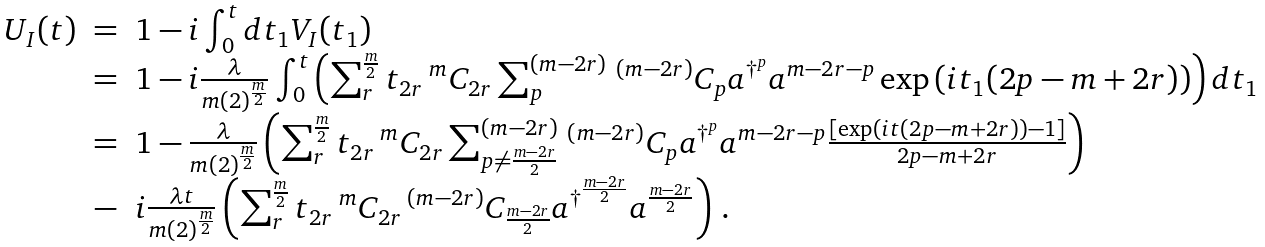Convert formula to latex. <formula><loc_0><loc_0><loc_500><loc_500>\begin{array} { l c l } U _ { I } ( t ) & = & 1 - i \int ^ { t } _ { 0 } d t _ { 1 } V _ { I } ( t _ { 1 } ) \\ & = & 1 - i \frac { \lambda } { m ( 2 ) ^ { \frac { m } { 2 } } } \int ^ { t } _ { 0 } \left ( \sum ^ { \frac { m } { 2 } } _ { r } t _ { 2 r } \, ^ { m } C _ { 2 r } \sum ^ { ( m - 2 r ) } _ { p } \, ^ { ( m - 2 r ) } C _ { p } a ^ { \dagger ^ { p } } a ^ { m - 2 r - p } \exp \left ( i t _ { 1 } ( 2 p - m + 2 r ) \right ) \right ) d t _ { 1 } \\ & = & 1 - \frac { \lambda } { m ( 2 ) ^ { \frac { m } { 2 } } } \left ( \sum ^ { \frac { m } { 2 } } _ { r } t _ { 2 r } \, ^ { m } C _ { 2 r } \sum ^ { ( m - 2 r ) } _ { p \neq \frac { m - 2 r } { 2 } } \, ^ { ( m - 2 r ) } C _ { p } a ^ { \dagger ^ { p } } a ^ { m - 2 r - p } \frac { \left [ \exp \left ( i t ( 2 p - m + 2 r ) \right ) - 1 \right ] } { 2 p - m + 2 r } \right ) \\ & - & i \frac { \lambda t } { m ( 2 ) ^ { \frac { m } { 2 } } } \left ( \sum ^ { \frac { m } { 2 } } _ { r } t _ { 2 r } \, ^ { m } C _ { 2 r } \, ^ { ( m - 2 r ) } C _ { \frac { m - 2 r } { 2 } } a ^ { \dagger ^ { \frac { m - 2 r } { 2 } } } a ^ { \frac { m - 2 r } { 2 } } \right ) \, . \\ & & \end{array}</formula> 